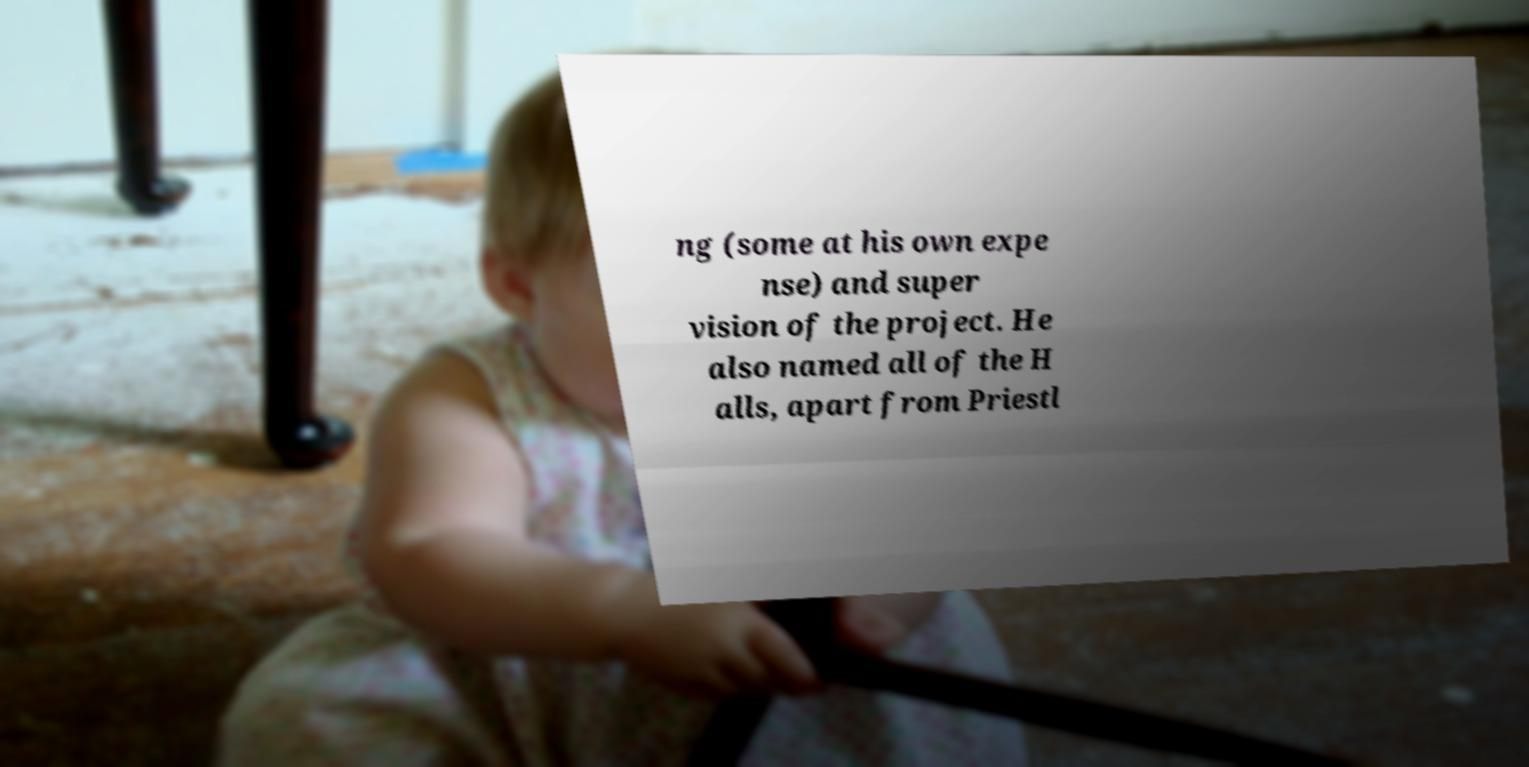I need the written content from this picture converted into text. Can you do that? ng (some at his own expe nse) and super vision of the project. He also named all of the H alls, apart from Priestl 